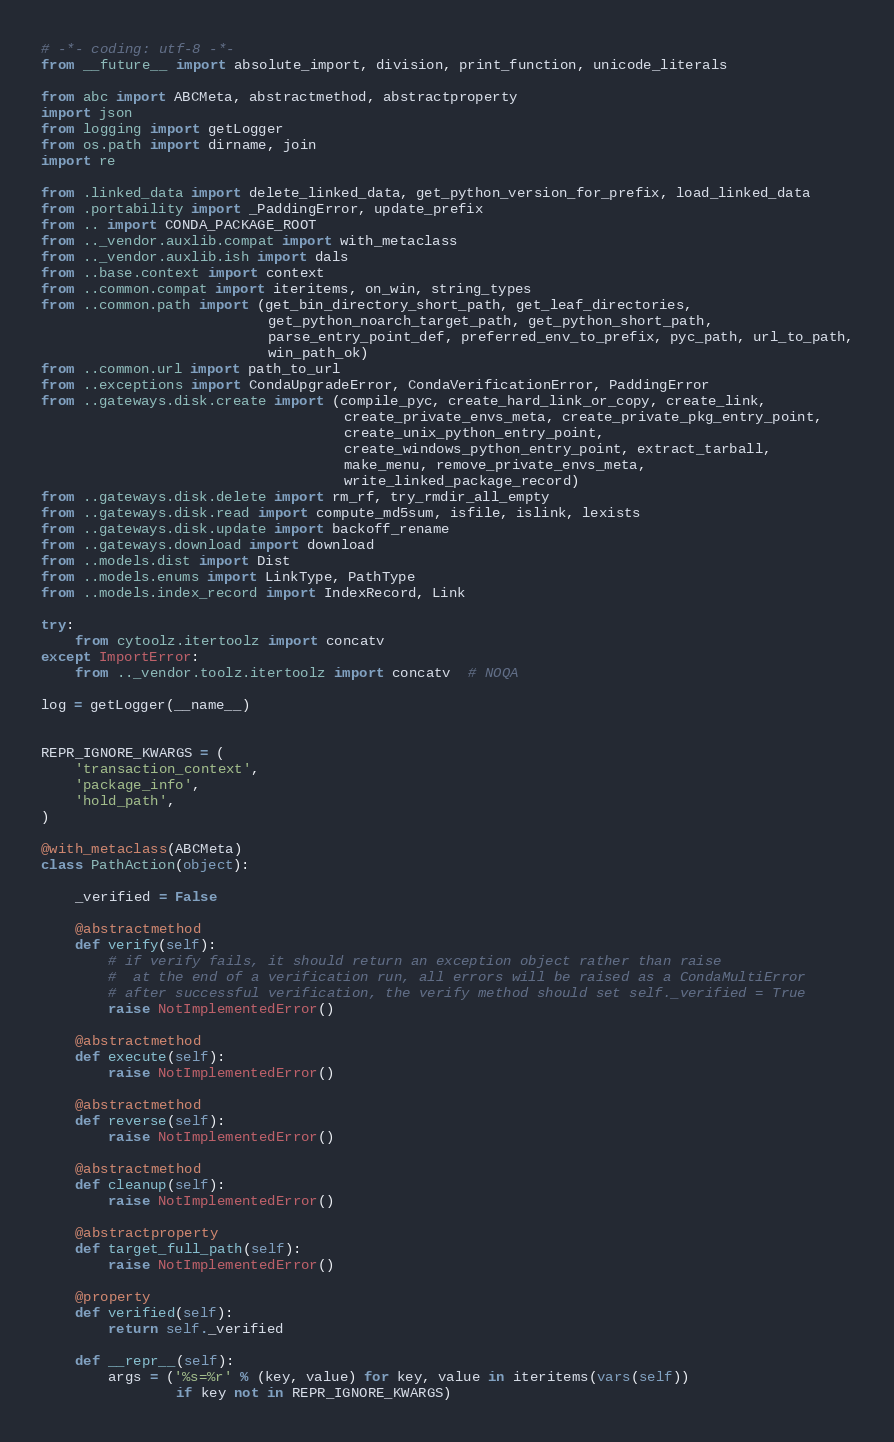Convert code to text. <code><loc_0><loc_0><loc_500><loc_500><_Python_># -*- coding: utf-8 -*-
from __future__ import absolute_import, division, print_function, unicode_literals

from abc import ABCMeta, abstractmethod, abstractproperty
import json
from logging import getLogger
from os.path import dirname, join
import re

from .linked_data import delete_linked_data, get_python_version_for_prefix, load_linked_data
from .portability import _PaddingError, update_prefix
from .. import CONDA_PACKAGE_ROOT
from .._vendor.auxlib.compat import with_metaclass
from .._vendor.auxlib.ish import dals
from ..base.context import context
from ..common.compat import iteritems, on_win, string_types
from ..common.path import (get_bin_directory_short_path, get_leaf_directories,
                           get_python_noarch_target_path, get_python_short_path,
                           parse_entry_point_def, preferred_env_to_prefix, pyc_path, url_to_path,
                           win_path_ok)
from ..common.url import path_to_url
from ..exceptions import CondaUpgradeError, CondaVerificationError, PaddingError
from ..gateways.disk.create import (compile_pyc, create_hard_link_or_copy, create_link,
                                    create_private_envs_meta, create_private_pkg_entry_point,
                                    create_unix_python_entry_point,
                                    create_windows_python_entry_point, extract_tarball,
                                    make_menu, remove_private_envs_meta,
                                    write_linked_package_record)
from ..gateways.disk.delete import rm_rf, try_rmdir_all_empty
from ..gateways.disk.read import compute_md5sum, isfile, islink, lexists
from ..gateways.disk.update import backoff_rename
from ..gateways.download import download
from ..models.dist import Dist
from ..models.enums import LinkType, PathType
from ..models.index_record import IndexRecord, Link

try:
    from cytoolz.itertoolz import concatv
except ImportError:
    from .._vendor.toolz.itertoolz import concatv  # NOQA

log = getLogger(__name__)


REPR_IGNORE_KWARGS = (
    'transaction_context',
    'package_info',
    'hold_path',
)

@with_metaclass(ABCMeta)
class PathAction(object):

    _verified = False

    @abstractmethod
    def verify(self):
        # if verify fails, it should return an exception object rather than raise
        #  at the end of a verification run, all errors will be raised as a CondaMultiError
        # after successful verification, the verify method should set self._verified = True
        raise NotImplementedError()

    @abstractmethod
    def execute(self):
        raise NotImplementedError()

    @abstractmethod
    def reverse(self):
        raise NotImplementedError()

    @abstractmethod
    def cleanup(self):
        raise NotImplementedError()

    @abstractproperty
    def target_full_path(self):
        raise NotImplementedError()

    @property
    def verified(self):
        return self._verified

    def __repr__(self):
        args = ('%s=%r' % (key, value) for key, value in iteritems(vars(self))
                if key not in REPR_IGNORE_KWARGS)</code> 